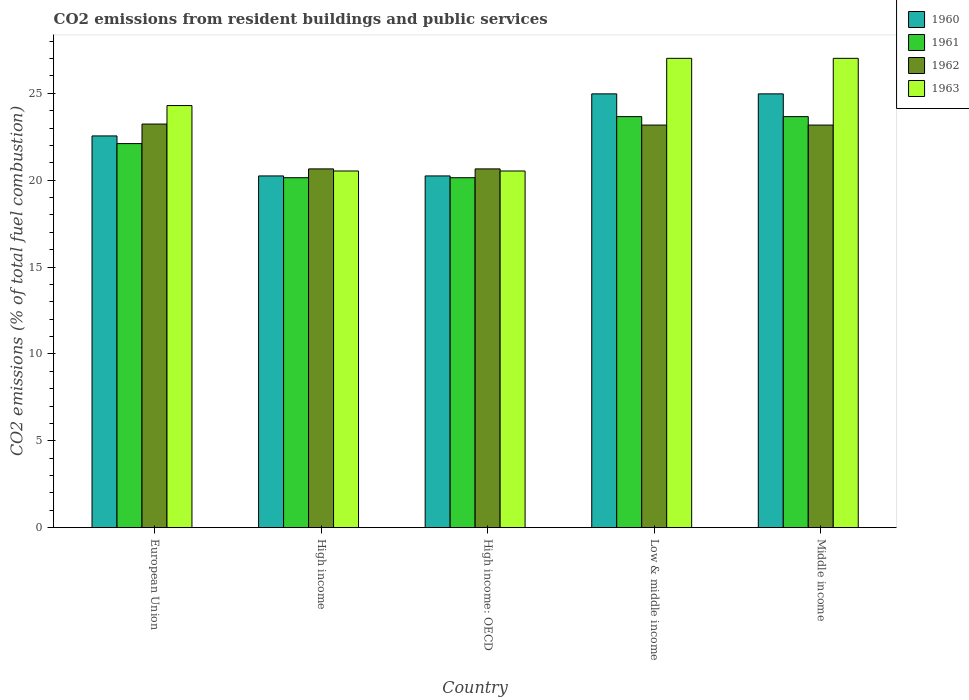How many groups of bars are there?
Keep it short and to the point. 5. How many bars are there on the 2nd tick from the left?
Provide a short and direct response. 4. How many bars are there on the 5th tick from the right?
Your answer should be very brief. 4. What is the total CO2 emitted in 1961 in High income?
Make the answer very short. 20.14. Across all countries, what is the maximum total CO2 emitted in 1961?
Ensure brevity in your answer.  23.66. Across all countries, what is the minimum total CO2 emitted in 1963?
Provide a succinct answer. 20.53. What is the total total CO2 emitted in 1961 in the graph?
Your answer should be very brief. 109.71. What is the difference between the total CO2 emitted in 1960 in High income: OECD and that in Middle income?
Give a very brief answer. -4.72. What is the difference between the total CO2 emitted in 1961 in Low & middle income and the total CO2 emitted in 1963 in Middle income?
Provide a short and direct response. -3.36. What is the average total CO2 emitted in 1960 per country?
Ensure brevity in your answer.  22.6. What is the difference between the total CO2 emitted of/in 1961 and total CO2 emitted of/in 1960 in High income: OECD?
Your response must be concise. -0.1. In how many countries, is the total CO2 emitted in 1962 greater than 11?
Provide a succinct answer. 5. Is the total CO2 emitted in 1963 in Low & middle income less than that in Middle income?
Keep it short and to the point. No. What is the difference between the highest and the second highest total CO2 emitted in 1963?
Make the answer very short. -2.72. What is the difference between the highest and the lowest total CO2 emitted in 1962?
Your answer should be compact. 2.58. In how many countries, is the total CO2 emitted in 1961 greater than the average total CO2 emitted in 1961 taken over all countries?
Offer a terse response. 3. What does the 3rd bar from the left in Low & middle income represents?
Your answer should be very brief. 1962. Is it the case that in every country, the sum of the total CO2 emitted in 1961 and total CO2 emitted in 1962 is greater than the total CO2 emitted in 1963?
Offer a very short reply. Yes. Does the graph contain grids?
Ensure brevity in your answer.  No. How are the legend labels stacked?
Provide a short and direct response. Vertical. What is the title of the graph?
Give a very brief answer. CO2 emissions from resident buildings and public services. What is the label or title of the Y-axis?
Your response must be concise. CO2 emissions (% of total fuel combustion). What is the CO2 emissions (% of total fuel combustion) in 1960 in European Union?
Offer a terse response. 22.55. What is the CO2 emissions (% of total fuel combustion) in 1961 in European Union?
Ensure brevity in your answer.  22.11. What is the CO2 emissions (% of total fuel combustion) of 1962 in European Union?
Your response must be concise. 23.23. What is the CO2 emissions (% of total fuel combustion) of 1963 in European Union?
Ensure brevity in your answer.  24.3. What is the CO2 emissions (% of total fuel combustion) in 1960 in High income?
Give a very brief answer. 20.25. What is the CO2 emissions (% of total fuel combustion) of 1961 in High income?
Give a very brief answer. 20.14. What is the CO2 emissions (% of total fuel combustion) of 1962 in High income?
Your response must be concise. 20.65. What is the CO2 emissions (% of total fuel combustion) of 1963 in High income?
Your response must be concise. 20.53. What is the CO2 emissions (% of total fuel combustion) of 1960 in High income: OECD?
Ensure brevity in your answer.  20.25. What is the CO2 emissions (% of total fuel combustion) in 1961 in High income: OECD?
Your answer should be compact. 20.14. What is the CO2 emissions (% of total fuel combustion) in 1962 in High income: OECD?
Offer a terse response. 20.65. What is the CO2 emissions (% of total fuel combustion) of 1963 in High income: OECD?
Provide a succinct answer. 20.53. What is the CO2 emissions (% of total fuel combustion) in 1960 in Low & middle income?
Make the answer very short. 24.97. What is the CO2 emissions (% of total fuel combustion) in 1961 in Low & middle income?
Give a very brief answer. 23.66. What is the CO2 emissions (% of total fuel combustion) of 1962 in Low & middle income?
Offer a very short reply. 23.17. What is the CO2 emissions (% of total fuel combustion) in 1963 in Low & middle income?
Your answer should be very brief. 27.01. What is the CO2 emissions (% of total fuel combustion) in 1960 in Middle income?
Your response must be concise. 24.97. What is the CO2 emissions (% of total fuel combustion) of 1961 in Middle income?
Your answer should be very brief. 23.66. What is the CO2 emissions (% of total fuel combustion) of 1962 in Middle income?
Provide a short and direct response. 23.17. What is the CO2 emissions (% of total fuel combustion) of 1963 in Middle income?
Your answer should be compact. 27.01. Across all countries, what is the maximum CO2 emissions (% of total fuel combustion) in 1960?
Your response must be concise. 24.97. Across all countries, what is the maximum CO2 emissions (% of total fuel combustion) in 1961?
Provide a succinct answer. 23.66. Across all countries, what is the maximum CO2 emissions (% of total fuel combustion) of 1962?
Ensure brevity in your answer.  23.23. Across all countries, what is the maximum CO2 emissions (% of total fuel combustion) in 1963?
Offer a terse response. 27.01. Across all countries, what is the minimum CO2 emissions (% of total fuel combustion) of 1960?
Provide a succinct answer. 20.25. Across all countries, what is the minimum CO2 emissions (% of total fuel combustion) of 1961?
Ensure brevity in your answer.  20.14. Across all countries, what is the minimum CO2 emissions (% of total fuel combustion) of 1962?
Your answer should be compact. 20.65. Across all countries, what is the minimum CO2 emissions (% of total fuel combustion) in 1963?
Give a very brief answer. 20.53. What is the total CO2 emissions (% of total fuel combustion) in 1960 in the graph?
Make the answer very short. 112.98. What is the total CO2 emissions (% of total fuel combustion) in 1961 in the graph?
Your answer should be very brief. 109.71. What is the total CO2 emissions (% of total fuel combustion) in 1962 in the graph?
Provide a succinct answer. 110.88. What is the total CO2 emissions (% of total fuel combustion) of 1963 in the graph?
Your answer should be very brief. 119.39. What is the difference between the CO2 emissions (% of total fuel combustion) of 1960 in European Union and that in High income?
Your answer should be very brief. 2.3. What is the difference between the CO2 emissions (% of total fuel combustion) of 1961 in European Union and that in High income?
Provide a short and direct response. 1.96. What is the difference between the CO2 emissions (% of total fuel combustion) of 1962 in European Union and that in High income?
Ensure brevity in your answer.  2.58. What is the difference between the CO2 emissions (% of total fuel combustion) of 1963 in European Union and that in High income?
Make the answer very short. 3.77. What is the difference between the CO2 emissions (% of total fuel combustion) of 1960 in European Union and that in High income: OECD?
Provide a succinct answer. 2.3. What is the difference between the CO2 emissions (% of total fuel combustion) in 1961 in European Union and that in High income: OECD?
Your answer should be very brief. 1.96. What is the difference between the CO2 emissions (% of total fuel combustion) in 1962 in European Union and that in High income: OECD?
Provide a succinct answer. 2.58. What is the difference between the CO2 emissions (% of total fuel combustion) of 1963 in European Union and that in High income: OECD?
Your answer should be very brief. 3.77. What is the difference between the CO2 emissions (% of total fuel combustion) in 1960 in European Union and that in Low & middle income?
Your response must be concise. -2.42. What is the difference between the CO2 emissions (% of total fuel combustion) in 1961 in European Union and that in Low & middle income?
Make the answer very short. -1.55. What is the difference between the CO2 emissions (% of total fuel combustion) of 1962 in European Union and that in Low & middle income?
Your answer should be compact. 0.06. What is the difference between the CO2 emissions (% of total fuel combustion) in 1963 in European Union and that in Low & middle income?
Provide a succinct answer. -2.72. What is the difference between the CO2 emissions (% of total fuel combustion) in 1960 in European Union and that in Middle income?
Ensure brevity in your answer.  -2.42. What is the difference between the CO2 emissions (% of total fuel combustion) in 1961 in European Union and that in Middle income?
Keep it short and to the point. -1.55. What is the difference between the CO2 emissions (% of total fuel combustion) in 1962 in European Union and that in Middle income?
Ensure brevity in your answer.  0.06. What is the difference between the CO2 emissions (% of total fuel combustion) of 1963 in European Union and that in Middle income?
Keep it short and to the point. -2.72. What is the difference between the CO2 emissions (% of total fuel combustion) in 1960 in High income and that in Low & middle income?
Give a very brief answer. -4.72. What is the difference between the CO2 emissions (% of total fuel combustion) in 1961 in High income and that in Low & middle income?
Your response must be concise. -3.52. What is the difference between the CO2 emissions (% of total fuel combustion) in 1962 in High income and that in Low & middle income?
Make the answer very short. -2.52. What is the difference between the CO2 emissions (% of total fuel combustion) of 1963 in High income and that in Low & middle income?
Offer a terse response. -6.48. What is the difference between the CO2 emissions (% of total fuel combustion) of 1960 in High income and that in Middle income?
Offer a very short reply. -4.72. What is the difference between the CO2 emissions (% of total fuel combustion) of 1961 in High income and that in Middle income?
Your response must be concise. -3.52. What is the difference between the CO2 emissions (% of total fuel combustion) of 1962 in High income and that in Middle income?
Keep it short and to the point. -2.52. What is the difference between the CO2 emissions (% of total fuel combustion) in 1963 in High income and that in Middle income?
Provide a short and direct response. -6.48. What is the difference between the CO2 emissions (% of total fuel combustion) of 1960 in High income: OECD and that in Low & middle income?
Provide a succinct answer. -4.72. What is the difference between the CO2 emissions (% of total fuel combustion) of 1961 in High income: OECD and that in Low & middle income?
Make the answer very short. -3.52. What is the difference between the CO2 emissions (% of total fuel combustion) in 1962 in High income: OECD and that in Low & middle income?
Make the answer very short. -2.52. What is the difference between the CO2 emissions (% of total fuel combustion) in 1963 in High income: OECD and that in Low & middle income?
Offer a terse response. -6.48. What is the difference between the CO2 emissions (% of total fuel combustion) of 1960 in High income: OECD and that in Middle income?
Make the answer very short. -4.72. What is the difference between the CO2 emissions (% of total fuel combustion) in 1961 in High income: OECD and that in Middle income?
Make the answer very short. -3.52. What is the difference between the CO2 emissions (% of total fuel combustion) of 1962 in High income: OECD and that in Middle income?
Ensure brevity in your answer.  -2.52. What is the difference between the CO2 emissions (% of total fuel combustion) in 1963 in High income: OECD and that in Middle income?
Make the answer very short. -6.48. What is the difference between the CO2 emissions (% of total fuel combustion) in 1960 in Low & middle income and that in Middle income?
Provide a short and direct response. 0. What is the difference between the CO2 emissions (% of total fuel combustion) in 1961 in Low & middle income and that in Middle income?
Make the answer very short. 0. What is the difference between the CO2 emissions (% of total fuel combustion) in 1962 in Low & middle income and that in Middle income?
Make the answer very short. 0. What is the difference between the CO2 emissions (% of total fuel combustion) of 1960 in European Union and the CO2 emissions (% of total fuel combustion) of 1961 in High income?
Give a very brief answer. 2.41. What is the difference between the CO2 emissions (% of total fuel combustion) in 1960 in European Union and the CO2 emissions (% of total fuel combustion) in 1962 in High income?
Your answer should be very brief. 1.9. What is the difference between the CO2 emissions (% of total fuel combustion) in 1960 in European Union and the CO2 emissions (% of total fuel combustion) in 1963 in High income?
Your response must be concise. 2.02. What is the difference between the CO2 emissions (% of total fuel combustion) in 1961 in European Union and the CO2 emissions (% of total fuel combustion) in 1962 in High income?
Make the answer very short. 1.46. What is the difference between the CO2 emissions (% of total fuel combustion) of 1961 in European Union and the CO2 emissions (% of total fuel combustion) of 1963 in High income?
Provide a short and direct response. 1.58. What is the difference between the CO2 emissions (% of total fuel combustion) in 1962 in European Union and the CO2 emissions (% of total fuel combustion) in 1963 in High income?
Your response must be concise. 2.7. What is the difference between the CO2 emissions (% of total fuel combustion) in 1960 in European Union and the CO2 emissions (% of total fuel combustion) in 1961 in High income: OECD?
Provide a short and direct response. 2.41. What is the difference between the CO2 emissions (% of total fuel combustion) in 1960 in European Union and the CO2 emissions (% of total fuel combustion) in 1962 in High income: OECD?
Your answer should be very brief. 1.9. What is the difference between the CO2 emissions (% of total fuel combustion) of 1960 in European Union and the CO2 emissions (% of total fuel combustion) of 1963 in High income: OECD?
Give a very brief answer. 2.02. What is the difference between the CO2 emissions (% of total fuel combustion) in 1961 in European Union and the CO2 emissions (% of total fuel combustion) in 1962 in High income: OECD?
Give a very brief answer. 1.46. What is the difference between the CO2 emissions (% of total fuel combustion) in 1961 in European Union and the CO2 emissions (% of total fuel combustion) in 1963 in High income: OECD?
Your answer should be compact. 1.58. What is the difference between the CO2 emissions (% of total fuel combustion) in 1962 in European Union and the CO2 emissions (% of total fuel combustion) in 1963 in High income: OECD?
Your response must be concise. 2.7. What is the difference between the CO2 emissions (% of total fuel combustion) of 1960 in European Union and the CO2 emissions (% of total fuel combustion) of 1961 in Low & middle income?
Your answer should be compact. -1.11. What is the difference between the CO2 emissions (% of total fuel combustion) in 1960 in European Union and the CO2 emissions (% of total fuel combustion) in 1962 in Low & middle income?
Your answer should be very brief. -0.62. What is the difference between the CO2 emissions (% of total fuel combustion) of 1960 in European Union and the CO2 emissions (% of total fuel combustion) of 1963 in Low & middle income?
Ensure brevity in your answer.  -4.47. What is the difference between the CO2 emissions (% of total fuel combustion) in 1961 in European Union and the CO2 emissions (% of total fuel combustion) in 1962 in Low & middle income?
Provide a short and direct response. -1.07. What is the difference between the CO2 emissions (% of total fuel combustion) in 1961 in European Union and the CO2 emissions (% of total fuel combustion) in 1963 in Low & middle income?
Offer a very short reply. -4.91. What is the difference between the CO2 emissions (% of total fuel combustion) of 1962 in European Union and the CO2 emissions (% of total fuel combustion) of 1963 in Low & middle income?
Make the answer very short. -3.78. What is the difference between the CO2 emissions (% of total fuel combustion) in 1960 in European Union and the CO2 emissions (% of total fuel combustion) in 1961 in Middle income?
Give a very brief answer. -1.11. What is the difference between the CO2 emissions (% of total fuel combustion) in 1960 in European Union and the CO2 emissions (% of total fuel combustion) in 1962 in Middle income?
Offer a very short reply. -0.62. What is the difference between the CO2 emissions (% of total fuel combustion) in 1960 in European Union and the CO2 emissions (% of total fuel combustion) in 1963 in Middle income?
Make the answer very short. -4.47. What is the difference between the CO2 emissions (% of total fuel combustion) of 1961 in European Union and the CO2 emissions (% of total fuel combustion) of 1962 in Middle income?
Your answer should be compact. -1.07. What is the difference between the CO2 emissions (% of total fuel combustion) of 1961 in European Union and the CO2 emissions (% of total fuel combustion) of 1963 in Middle income?
Make the answer very short. -4.91. What is the difference between the CO2 emissions (% of total fuel combustion) of 1962 in European Union and the CO2 emissions (% of total fuel combustion) of 1963 in Middle income?
Your answer should be compact. -3.78. What is the difference between the CO2 emissions (% of total fuel combustion) of 1960 in High income and the CO2 emissions (% of total fuel combustion) of 1961 in High income: OECD?
Provide a succinct answer. 0.1. What is the difference between the CO2 emissions (% of total fuel combustion) of 1960 in High income and the CO2 emissions (% of total fuel combustion) of 1962 in High income: OECD?
Provide a short and direct response. -0.4. What is the difference between the CO2 emissions (% of total fuel combustion) of 1960 in High income and the CO2 emissions (% of total fuel combustion) of 1963 in High income: OECD?
Your answer should be very brief. -0.28. What is the difference between the CO2 emissions (% of total fuel combustion) of 1961 in High income and the CO2 emissions (% of total fuel combustion) of 1962 in High income: OECD?
Keep it short and to the point. -0.51. What is the difference between the CO2 emissions (% of total fuel combustion) in 1961 in High income and the CO2 emissions (% of total fuel combustion) in 1963 in High income: OECD?
Your answer should be compact. -0.39. What is the difference between the CO2 emissions (% of total fuel combustion) in 1962 in High income and the CO2 emissions (% of total fuel combustion) in 1963 in High income: OECD?
Provide a succinct answer. 0.12. What is the difference between the CO2 emissions (% of total fuel combustion) of 1960 in High income and the CO2 emissions (% of total fuel combustion) of 1961 in Low & middle income?
Offer a terse response. -3.41. What is the difference between the CO2 emissions (% of total fuel combustion) of 1960 in High income and the CO2 emissions (% of total fuel combustion) of 1962 in Low & middle income?
Provide a succinct answer. -2.93. What is the difference between the CO2 emissions (% of total fuel combustion) in 1960 in High income and the CO2 emissions (% of total fuel combustion) in 1963 in Low & middle income?
Provide a short and direct response. -6.77. What is the difference between the CO2 emissions (% of total fuel combustion) of 1961 in High income and the CO2 emissions (% of total fuel combustion) of 1962 in Low & middle income?
Provide a succinct answer. -3.03. What is the difference between the CO2 emissions (% of total fuel combustion) of 1961 in High income and the CO2 emissions (% of total fuel combustion) of 1963 in Low & middle income?
Provide a succinct answer. -6.87. What is the difference between the CO2 emissions (% of total fuel combustion) in 1962 in High income and the CO2 emissions (% of total fuel combustion) in 1963 in Low & middle income?
Give a very brief answer. -6.36. What is the difference between the CO2 emissions (% of total fuel combustion) of 1960 in High income and the CO2 emissions (% of total fuel combustion) of 1961 in Middle income?
Make the answer very short. -3.41. What is the difference between the CO2 emissions (% of total fuel combustion) of 1960 in High income and the CO2 emissions (% of total fuel combustion) of 1962 in Middle income?
Offer a very short reply. -2.93. What is the difference between the CO2 emissions (% of total fuel combustion) in 1960 in High income and the CO2 emissions (% of total fuel combustion) in 1963 in Middle income?
Ensure brevity in your answer.  -6.77. What is the difference between the CO2 emissions (% of total fuel combustion) in 1961 in High income and the CO2 emissions (% of total fuel combustion) in 1962 in Middle income?
Make the answer very short. -3.03. What is the difference between the CO2 emissions (% of total fuel combustion) of 1961 in High income and the CO2 emissions (% of total fuel combustion) of 1963 in Middle income?
Keep it short and to the point. -6.87. What is the difference between the CO2 emissions (% of total fuel combustion) of 1962 in High income and the CO2 emissions (% of total fuel combustion) of 1963 in Middle income?
Keep it short and to the point. -6.36. What is the difference between the CO2 emissions (% of total fuel combustion) of 1960 in High income: OECD and the CO2 emissions (% of total fuel combustion) of 1961 in Low & middle income?
Your answer should be very brief. -3.41. What is the difference between the CO2 emissions (% of total fuel combustion) in 1960 in High income: OECD and the CO2 emissions (% of total fuel combustion) in 1962 in Low & middle income?
Your answer should be compact. -2.93. What is the difference between the CO2 emissions (% of total fuel combustion) of 1960 in High income: OECD and the CO2 emissions (% of total fuel combustion) of 1963 in Low & middle income?
Your answer should be very brief. -6.77. What is the difference between the CO2 emissions (% of total fuel combustion) of 1961 in High income: OECD and the CO2 emissions (% of total fuel combustion) of 1962 in Low & middle income?
Provide a short and direct response. -3.03. What is the difference between the CO2 emissions (% of total fuel combustion) in 1961 in High income: OECD and the CO2 emissions (% of total fuel combustion) in 1963 in Low & middle income?
Keep it short and to the point. -6.87. What is the difference between the CO2 emissions (% of total fuel combustion) of 1962 in High income: OECD and the CO2 emissions (% of total fuel combustion) of 1963 in Low & middle income?
Provide a succinct answer. -6.36. What is the difference between the CO2 emissions (% of total fuel combustion) in 1960 in High income: OECD and the CO2 emissions (% of total fuel combustion) in 1961 in Middle income?
Keep it short and to the point. -3.41. What is the difference between the CO2 emissions (% of total fuel combustion) in 1960 in High income: OECD and the CO2 emissions (% of total fuel combustion) in 1962 in Middle income?
Give a very brief answer. -2.93. What is the difference between the CO2 emissions (% of total fuel combustion) in 1960 in High income: OECD and the CO2 emissions (% of total fuel combustion) in 1963 in Middle income?
Provide a short and direct response. -6.77. What is the difference between the CO2 emissions (% of total fuel combustion) in 1961 in High income: OECD and the CO2 emissions (% of total fuel combustion) in 1962 in Middle income?
Keep it short and to the point. -3.03. What is the difference between the CO2 emissions (% of total fuel combustion) of 1961 in High income: OECD and the CO2 emissions (% of total fuel combustion) of 1963 in Middle income?
Ensure brevity in your answer.  -6.87. What is the difference between the CO2 emissions (% of total fuel combustion) of 1962 in High income: OECD and the CO2 emissions (% of total fuel combustion) of 1963 in Middle income?
Your response must be concise. -6.36. What is the difference between the CO2 emissions (% of total fuel combustion) of 1960 in Low & middle income and the CO2 emissions (% of total fuel combustion) of 1961 in Middle income?
Your response must be concise. 1.31. What is the difference between the CO2 emissions (% of total fuel combustion) of 1960 in Low & middle income and the CO2 emissions (% of total fuel combustion) of 1962 in Middle income?
Ensure brevity in your answer.  1.8. What is the difference between the CO2 emissions (% of total fuel combustion) in 1960 in Low & middle income and the CO2 emissions (% of total fuel combustion) in 1963 in Middle income?
Your answer should be compact. -2.05. What is the difference between the CO2 emissions (% of total fuel combustion) of 1961 in Low & middle income and the CO2 emissions (% of total fuel combustion) of 1962 in Middle income?
Your response must be concise. 0.49. What is the difference between the CO2 emissions (% of total fuel combustion) of 1961 in Low & middle income and the CO2 emissions (% of total fuel combustion) of 1963 in Middle income?
Your answer should be very brief. -3.35. What is the difference between the CO2 emissions (% of total fuel combustion) of 1962 in Low & middle income and the CO2 emissions (% of total fuel combustion) of 1963 in Middle income?
Offer a terse response. -3.84. What is the average CO2 emissions (% of total fuel combustion) of 1960 per country?
Ensure brevity in your answer.  22.6. What is the average CO2 emissions (% of total fuel combustion) in 1961 per country?
Keep it short and to the point. 21.94. What is the average CO2 emissions (% of total fuel combustion) of 1962 per country?
Provide a succinct answer. 22.18. What is the average CO2 emissions (% of total fuel combustion) of 1963 per country?
Your response must be concise. 23.88. What is the difference between the CO2 emissions (% of total fuel combustion) in 1960 and CO2 emissions (% of total fuel combustion) in 1961 in European Union?
Your response must be concise. 0.44. What is the difference between the CO2 emissions (% of total fuel combustion) of 1960 and CO2 emissions (% of total fuel combustion) of 1962 in European Union?
Offer a terse response. -0.68. What is the difference between the CO2 emissions (% of total fuel combustion) in 1960 and CO2 emissions (% of total fuel combustion) in 1963 in European Union?
Make the answer very short. -1.75. What is the difference between the CO2 emissions (% of total fuel combustion) of 1961 and CO2 emissions (% of total fuel combustion) of 1962 in European Union?
Ensure brevity in your answer.  -1.13. What is the difference between the CO2 emissions (% of total fuel combustion) of 1961 and CO2 emissions (% of total fuel combustion) of 1963 in European Union?
Provide a succinct answer. -2.19. What is the difference between the CO2 emissions (% of total fuel combustion) in 1962 and CO2 emissions (% of total fuel combustion) in 1963 in European Union?
Give a very brief answer. -1.07. What is the difference between the CO2 emissions (% of total fuel combustion) in 1960 and CO2 emissions (% of total fuel combustion) in 1961 in High income?
Your response must be concise. 0.1. What is the difference between the CO2 emissions (% of total fuel combustion) in 1960 and CO2 emissions (% of total fuel combustion) in 1962 in High income?
Ensure brevity in your answer.  -0.4. What is the difference between the CO2 emissions (% of total fuel combustion) in 1960 and CO2 emissions (% of total fuel combustion) in 1963 in High income?
Keep it short and to the point. -0.28. What is the difference between the CO2 emissions (% of total fuel combustion) of 1961 and CO2 emissions (% of total fuel combustion) of 1962 in High income?
Provide a short and direct response. -0.51. What is the difference between the CO2 emissions (% of total fuel combustion) in 1961 and CO2 emissions (% of total fuel combustion) in 1963 in High income?
Ensure brevity in your answer.  -0.39. What is the difference between the CO2 emissions (% of total fuel combustion) of 1962 and CO2 emissions (% of total fuel combustion) of 1963 in High income?
Your answer should be very brief. 0.12. What is the difference between the CO2 emissions (% of total fuel combustion) in 1960 and CO2 emissions (% of total fuel combustion) in 1961 in High income: OECD?
Your answer should be very brief. 0.1. What is the difference between the CO2 emissions (% of total fuel combustion) in 1960 and CO2 emissions (% of total fuel combustion) in 1962 in High income: OECD?
Give a very brief answer. -0.4. What is the difference between the CO2 emissions (% of total fuel combustion) of 1960 and CO2 emissions (% of total fuel combustion) of 1963 in High income: OECD?
Your response must be concise. -0.28. What is the difference between the CO2 emissions (% of total fuel combustion) in 1961 and CO2 emissions (% of total fuel combustion) in 1962 in High income: OECD?
Your answer should be very brief. -0.51. What is the difference between the CO2 emissions (% of total fuel combustion) of 1961 and CO2 emissions (% of total fuel combustion) of 1963 in High income: OECD?
Offer a very short reply. -0.39. What is the difference between the CO2 emissions (% of total fuel combustion) in 1962 and CO2 emissions (% of total fuel combustion) in 1963 in High income: OECD?
Your answer should be compact. 0.12. What is the difference between the CO2 emissions (% of total fuel combustion) in 1960 and CO2 emissions (% of total fuel combustion) in 1961 in Low & middle income?
Your answer should be very brief. 1.31. What is the difference between the CO2 emissions (% of total fuel combustion) in 1960 and CO2 emissions (% of total fuel combustion) in 1962 in Low & middle income?
Make the answer very short. 1.8. What is the difference between the CO2 emissions (% of total fuel combustion) of 1960 and CO2 emissions (% of total fuel combustion) of 1963 in Low & middle income?
Make the answer very short. -2.05. What is the difference between the CO2 emissions (% of total fuel combustion) of 1961 and CO2 emissions (% of total fuel combustion) of 1962 in Low & middle income?
Keep it short and to the point. 0.49. What is the difference between the CO2 emissions (% of total fuel combustion) in 1961 and CO2 emissions (% of total fuel combustion) in 1963 in Low & middle income?
Your answer should be compact. -3.35. What is the difference between the CO2 emissions (% of total fuel combustion) in 1962 and CO2 emissions (% of total fuel combustion) in 1963 in Low & middle income?
Provide a short and direct response. -3.84. What is the difference between the CO2 emissions (% of total fuel combustion) of 1960 and CO2 emissions (% of total fuel combustion) of 1961 in Middle income?
Your answer should be compact. 1.31. What is the difference between the CO2 emissions (% of total fuel combustion) in 1960 and CO2 emissions (% of total fuel combustion) in 1962 in Middle income?
Give a very brief answer. 1.8. What is the difference between the CO2 emissions (% of total fuel combustion) of 1960 and CO2 emissions (% of total fuel combustion) of 1963 in Middle income?
Keep it short and to the point. -2.05. What is the difference between the CO2 emissions (% of total fuel combustion) in 1961 and CO2 emissions (% of total fuel combustion) in 1962 in Middle income?
Offer a terse response. 0.49. What is the difference between the CO2 emissions (% of total fuel combustion) in 1961 and CO2 emissions (% of total fuel combustion) in 1963 in Middle income?
Give a very brief answer. -3.35. What is the difference between the CO2 emissions (% of total fuel combustion) of 1962 and CO2 emissions (% of total fuel combustion) of 1963 in Middle income?
Offer a terse response. -3.84. What is the ratio of the CO2 emissions (% of total fuel combustion) of 1960 in European Union to that in High income?
Your response must be concise. 1.11. What is the ratio of the CO2 emissions (% of total fuel combustion) in 1961 in European Union to that in High income?
Your response must be concise. 1.1. What is the ratio of the CO2 emissions (% of total fuel combustion) of 1963 in European Union to that in High income?
Your response must be concise. 1.18. What is the ratio of the CO2 emissions (% of total fuel combustion) in 1960 in European Union to that in High income: OECD?
Ensure brevity in your answer.  1.11. What is the ratio of the CO2 emissions (% of total fuel combustion) of 1961 in European Union to that in High income: OECD?
Make the answer very short. 1.1. What is the ratio of the CO2 emissions (% of total fuel combustion) of 1962 in European Union to that in High income: OECD?
Your answer should be very brief. 1.12. What is the ratio of the CO2 emissions (% of total fuel combustion) of 1963 in European Union to that in High income: OECD?
Provide a short and direct response. 1.18. What is the ratio of the CO2 emissions (% of total fuel combustion) in 1960 in European Union to that in Low & middle income?
Make the answer very short. 0.9. What is the ratio of the CO2 emissions (% of total fuel combustion) in 1961 in European Union to that in Low & middle income?
Your answer should be compact. 0.93. What is the ratio of the CO2 emissions (% of total fuel combustion) of 1963 in European Union to that in Low & middle income?
Make the answer very short. 0.9. What is the ratio of the CO2 emissions (% of total fuel combustion) of 1960 in European Union to that in Middle income?
Your answer should be very brief. 0.9. What is the ratio of the CO2 emissions (% of total fuel combustion) of 1961 in European Union to that in Middle income?
Your answer should be very brief. 0.93. What is the ratio of the CO2 emissions (% of total fuel combustion) in 1963 in European Union to that in Middle income?
Your answer should be compact. 0.9. What is the ratio of the CO2 emissions (% of total fuel combustion) in 1960 in High income to that in High income: OECD?
Ensure brevity in your answer.  1. What is the ratio of the CO2 emissions (% of total fuel combustion) in 1962 in High income to that in High income: OECD?
Offer a terse response. 1. What is the ratio of the CO2 emissions (% of total fuel combustion) in 1960 in High income to that in Low & middle income?
Offer a terse response. 0.81. What is the ratio of the CO2 emissions (% of total fuel combustion) of 1961 in High income to that in Low & middle income?
Give a very brief answer. 0.85. What is the ratio of the CO2 emissions (% of total fuel combustion) of 1962 in High income to that in Low & middle income?
Offer a very short reply. 0.89. What is the ratio of the CO2 emissions (% of total fuel combustion) in 1963 in High income to that in Low & middle income?
Provide a short and direct response. 0.76. What is the ratio of the CO2 emissions (% of total fuel combustion) in 1960 in High income to that in Middle income?
Offer a terse response. 0.81. What is the ratio of the CO2 emissions (% of total fuel combustion) in 1961 in High income to that in Middle income?
Provide a succinct answer. 0.85. What is the ratio of the CO2 emissions (% of total fuel combustion) of 1962 in High income to that in Middle income?
Ensure brevity in your answer.  0.89. What is the ratio of the CO2 emissions (% of total fuel combustion) in 1963 in High income to that in Middle income?
Provide a short and direct response. 0.76. What is the ratio of the CO2 emissions (% of total fuel combustion) of 1960 in High income: OECD to that in Low & middle income?
Ensure brevity in your answer.  0.81. What is the ratio of the CO2 emissions (% of total fuel combustion) of 1961 in High income: OECD to that in Low & middle income?
Your answer should be very brief. 0.85. What is the ratio of the CO2 emissions (% of total fuel combustion) of 1962 in High income: OECD to that in Low & middle income?
Your response must be concise. 0.89. What is the ratio of the CO2 emissions (% of total fuel combustion) in 1963 in High income: OECD to that in Low & middle income?
Ensure brevity in your answer.  0.76. What is the ratio of the CO2 emissions (% of total fuel combustion) in 1960 in High income: OECD to that in Middle income?
Give a very brief answer. 0.81. What is the ratio of the CO2 emissions (% of total fuel combustion) of 1961 in High income: OECD to that in Middle income?
Give a very brief answer. 0.85. What is the ratio of the CO2 emissions (% of total fuel combustion) of 1962 in High income: OECD to that in Middle income?
Offer a terse response. 0.89. What is the ratio of the CO2 emissions (% of total fuel combustion) of 1963 in High income: OECD to that in Middle income?
Your response must be concise. 0.76. What is the ratio of the CO2 emissions (% of total fuel combustion) in 1961 in Low & middle income to that in Middle income?
Provide a succinct answer. 1. What is the ratio of the CO2 emissions (% of total fuel combustion) of 1963 in Low & middle income to that in Middle income?
Your answer should be very brief. 1. What is the difference between the highest and the second highest CO2 emissions (% of total fuel combustion) of 1961?
Offer a very short reply. 0. What is the difference between the highest and the second highest CO2 emissions (% of total fuel combustion) in 1962?
Your answer should be compact. 0.06. What is the difference between the highest and the second highest CO2 emissions (% of total fuel combustion) in 1963?
Provide a short and direct response. 0. What is the difference between the highest and the lowest CO2 emissions (% of total fuel combustion) in 1960?
Make the answer very short. 4.72. What is the difference between the highest and the lowest CO2 emissions (% of total fuel combustion) in 1961?
Give a very brief answer. 3.52. What is the difference between the highest and the lowest CO2 emissions (% of total fuel combustion) of 1962?
Ensure brevity in your answer.  2.58. What is the difference between the highest and the lowest CO2 emissions (% of total fuel combustion) in 1963?
Offer a very short reply. 6.48. 